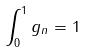<formula> <loc_0><loc_0><loc_500><loc_500>\int _ { 0 } ^ { 1 } g _ { n } = 1</formula> 